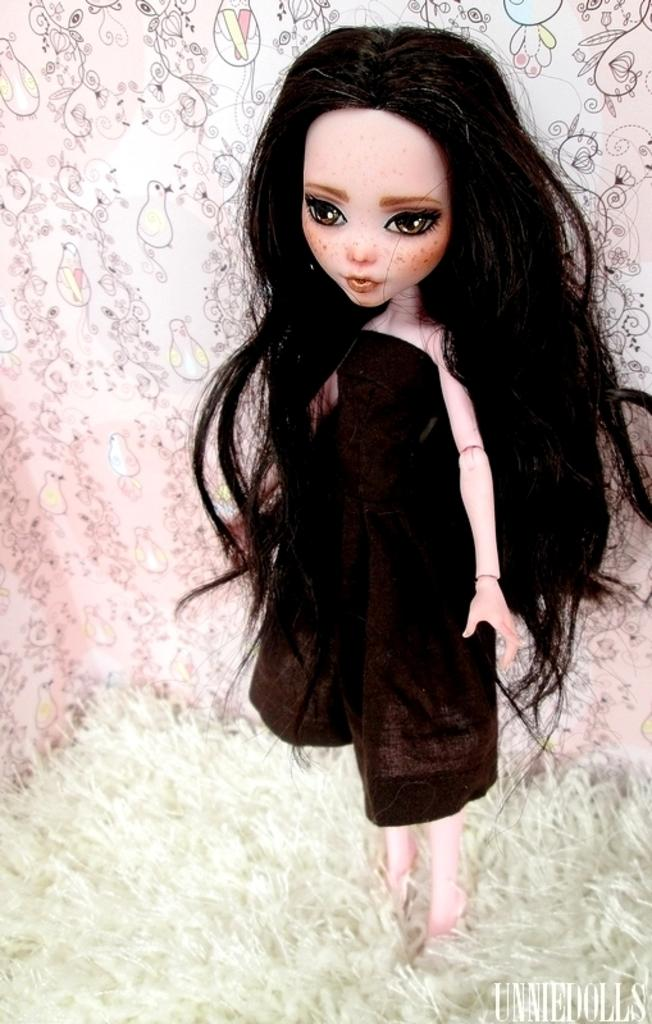What is the main subject of the image? There is a doll in the image. What else can be seen in the image besides the doll? There is a cloth in the image. Can you describe the background of the image? There is a wall design in the background of the image. Is there any text present in the image? Yes, there is some text at the right bottom of the image. What advice does the doll give to the ants in the image? There are no ants present in the image, so the doll cannot give any advice to them. 